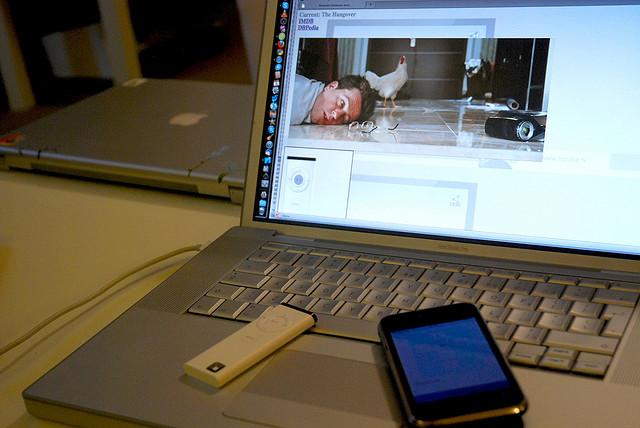How large is the laptop?
Keep it brief. 15 inch. Is the man in the computer sleeping?
Short answer required. No. What kind of computer is shown on the left in the back of the picture?
Be succinct. Laptop. What system does this computer operate using?
Answer briefly. Os x. What brand is the laptop?
Quick response, please. Apple. What is the mobile phone sitting on top of?
Give a very brief answer. Laptop. What animal is shown?
Write a very short answer. Chicken. What plays music in this photo?
Be succinct. Computer. What kind of bird is this?
Be succinct. Chicken. What operating system is the laptop running?
Be succinct. Windows. Is the laptop on?
Write a very short answer. Yes. What website is pulled up on the computer?
Short answer required. Google. What material is the computer stand made of?
Short answer required. Wood. Is the laptop dim?
Short answer required. No. 